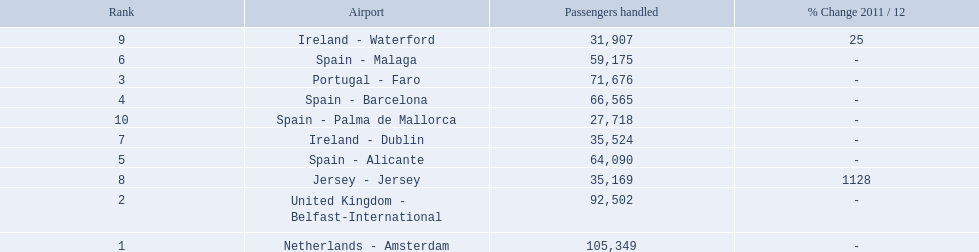Can you give me this table in json format? {'header': ['Rank', 'Airport', 'Passengers handled', '% Change 2011 / 12'], 'rows': [['9', 'Ireland - Waterford', '31,907', '25'], ['6', 'Spain - Malaga', '59,175', '-'], ['3', 'Portugal - Faro', '71,676', '-'], ['4', 'Spain - Barcelona', '66,565', '-'], ['10', 'Spain - Palma de Mallorca', '27,718', '-'], ['7', 'Ireland - Dublin', '35,524', '-'], ['5', 'Spain - Alicante', '64,090', '-'], ['8', 'Jersey - Jersey', '35,169', '1128'], ['2', 'United Kingdom - Belfast-International', '92,502', '-'], ['1', 'Netherlands - Amsterdam', '105,349', '-']]} What are all of the destinations out of the london southend airport? Netherlands - Amsterdam, United Kingdom - Belfast-International, Portugal - Faro, Spain - Barcelona, Spain - Alicante, Spain - Malaga, Ireland - Dublin, Jersey - Jersey, Ireland - Waterford, Spain - Palma de Mallorca. How many passengers has each destination handled? 105,349, 92,502, 71,676, 66,565, 64,090, 59,175, 35,524, 35,169, 31,907, 27,718. And of those, which airport handled the fewest passengers? Spain - Palma de Mallorca. 